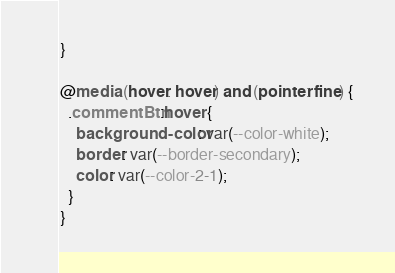Convert code to text. <code><loc_0><loc_0><loc_500><loc_500><_CSS_>}

@media (hover: hover) and (pointer: fine) {
  .commentBtn:hover {
    background-color: var(--color-white);
    border: var(--border-secondary);
    color: var(--color-2-1);
  }
}
</code> 